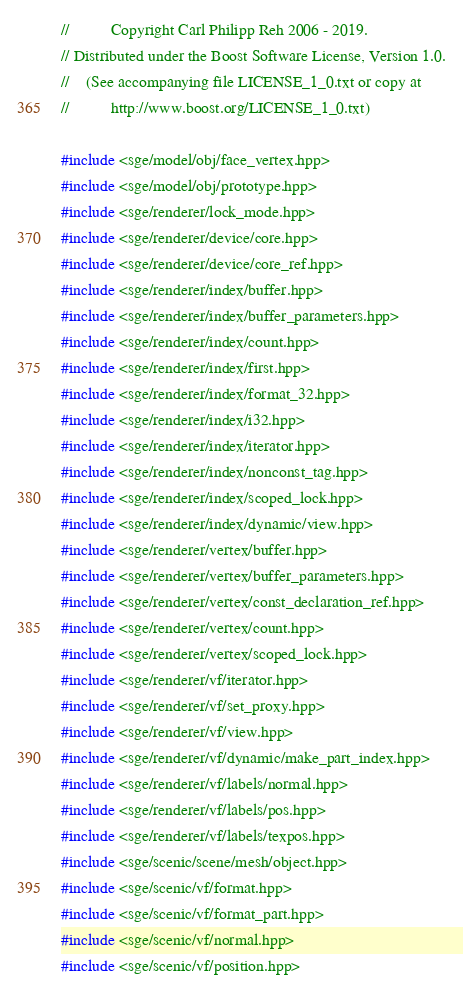<code> <loc_0><loc_0><loc_500><loc_500><_C++_>//          Copyright Carl Philipp Reh 2006 - 2019.
// Distributed under the Boost Software License, Version 1.0.
//    (See accompanying file LICENSE_1_0.txt or copy at
//          http://www.boost.org/LICENSE_1_0.txt)

#include <sge/model/obj/face_vertex.hpp>
#include <sge/model/obj/prototype.hpp>
#include <sge/renderer/lock_mode.hpp>
#include <sge/renderer/device/core.hpp>
#include <sge/renderer/device/core_ref.hpp>
#include <sge/renderer/index/buffer.hpp>
#include <sge/renderer/index/buffer_parameters.hpp>
#include <sge/renderer/index/count.hpp>
#include <sge/renderer/index/first.hpp>
#include <sge/renderer/index/format_32.hpp>
#include <sge/renderer/index/i32.hpp>
#include <sge/renderer/index/iterator.hpp>
#include <sge/renderer/index/nonconst_tag.hpp>
#include <sge/renderer/index/scoped_lock.hpp>
#include <sge/renderer/index/dynamic/view.hpp>
#include <sge/renderer/vertex/buffer.hpp>
#include <sge/renderer/vertex/buffer_parameters.hpp>
#include <sge/renderer/vertex/const_declaration_ref.hpp>
#include <sge/renderer/vertex/count.hpp>
#include <sge/renderer/vertex/scoped_lock.hpp>
#include <sge/renderer/vf/iterator.hpp>
#include <sge/renderer/vf/set_proxy.hpp>
#include <sge/renderer/vf/view.hpp>
#include <sge/renderer/vf/dynamic/make_part_index.hpp>
#include <sge/renderer/vf/labels/normal.hpp>
#include <sge/renderer/vf/labels/pos.hpp>
#include <sge/renderer/vf/labels/texpos.hpp>
#include <sge/scenic/scene/mesh/object.hpp>
#include <sge/scenic/vf/format.hpp>
#include <sge/scenic/vf/format_part.hpp>
#include <sge/scenic/vf/normal.hpp>
#include <sge/scenic/vf/position.hpp></code> 